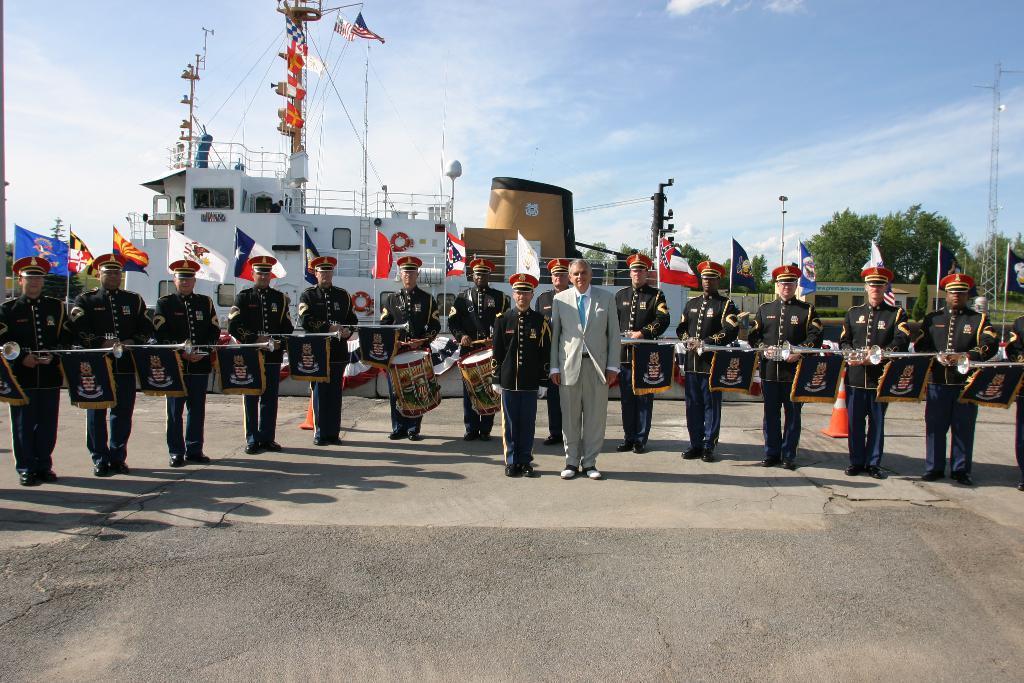Describe this image in one or two sentences. In this image there is the sky truncated towards the top of the image, there are clouds in the sky, there are flags, there are poles, there are trees truncated towards the right of the image, there are group of persons standing, there are persons holding an objects, there are objects on the ground, there is ground truncated towards the bottom of the image, there is an object truncated towards the left of the image, there is a person truncated towards the right of the image, there is a person truncated towards the left of the image. 